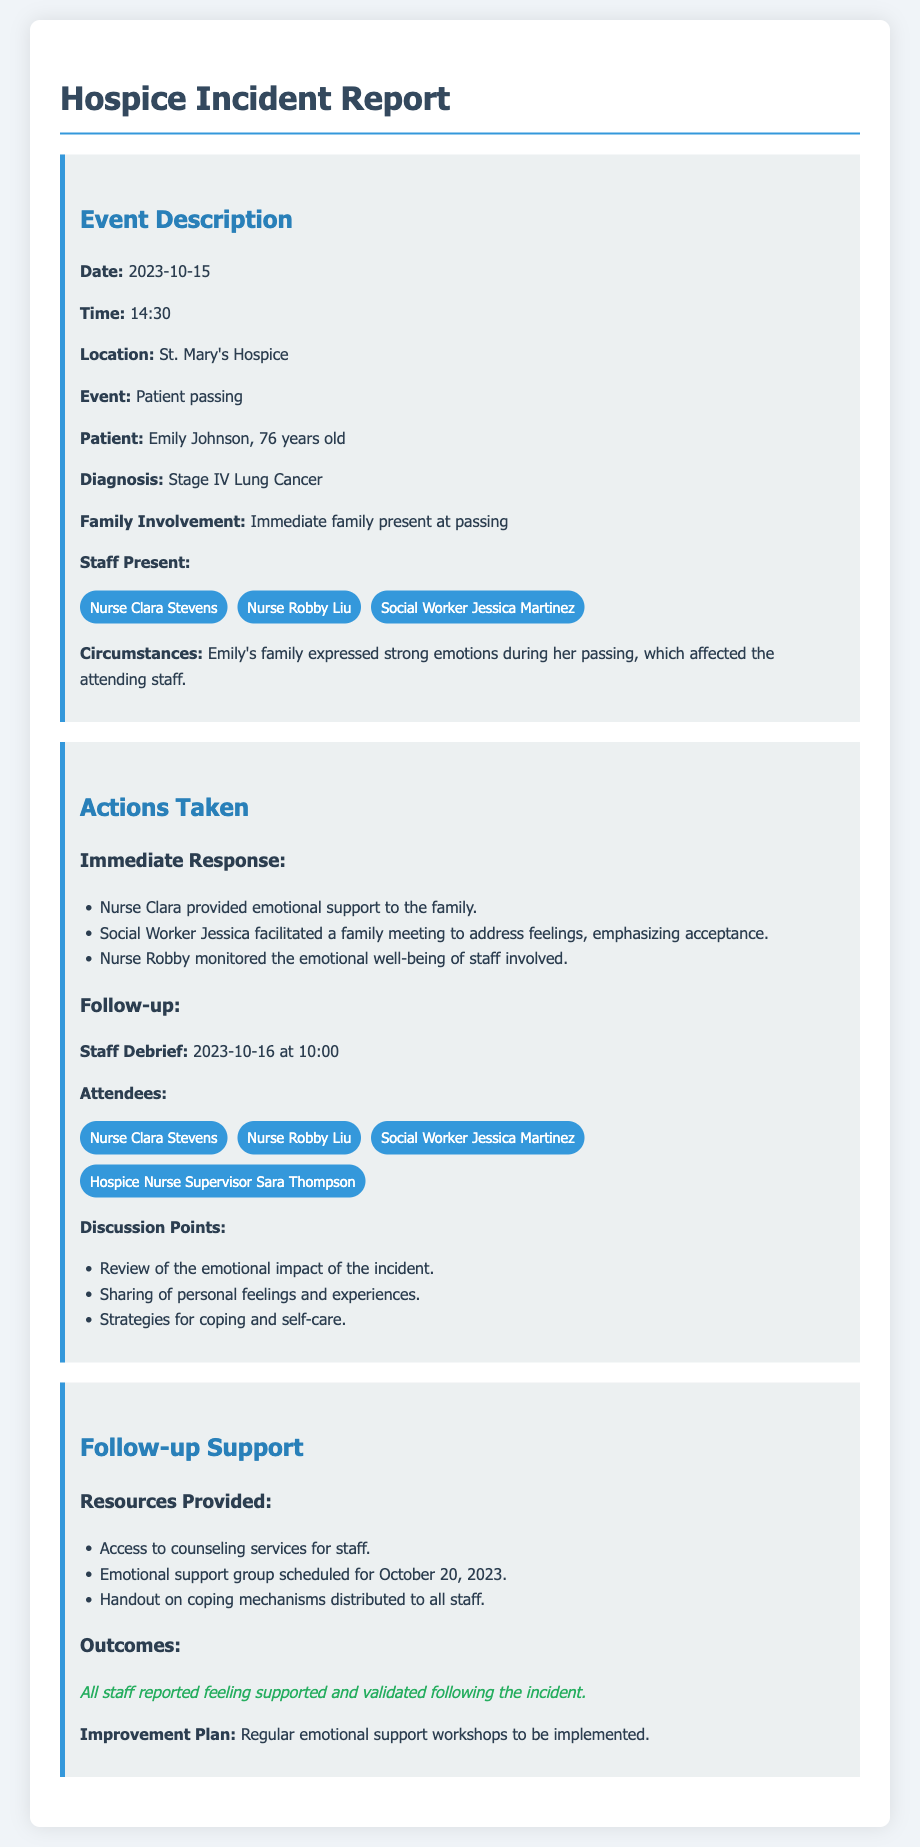what was the date of the event? The event date is clearly stated in the document within the event description section.
Answer: 2023-10-15 who was the patient in the incident? The document specifies the name of the patient in the event details section.
Answer: Emily Johnson how old was the patient? The age of the patient is mentioned in the event details, providing specific demographic information.
Answer: 76 years old what actions were taken by Nurse Clara? The document outlines the immediate response actions taken by Nurse Clara during the incident.
Answer: Provided emotional support to the family what was discussed in the staff debrief? The document lists several discussion points covered in the staff debrief regarding emotional impacts.
Answer: Review of the emotional impact of the incident how many staff members were present at the event? The event details list three staff members who were present during the incident.
Answer: Three what support resources were provided to staff? The follow-up support section lists specific resources offered to staff after the incident.
Answer: Access to counseling services for staff when is the emotional support group scheduled? The document clearly states the date of the scheduled emotional support group for the staff.
Answer: October 20, 2023 what was the outcome for the staff following the incident? The outcomes section summarizes the feelings expressed by the staff after receiving support.
Answer: All staff reported feeling supported and validated following the incident 